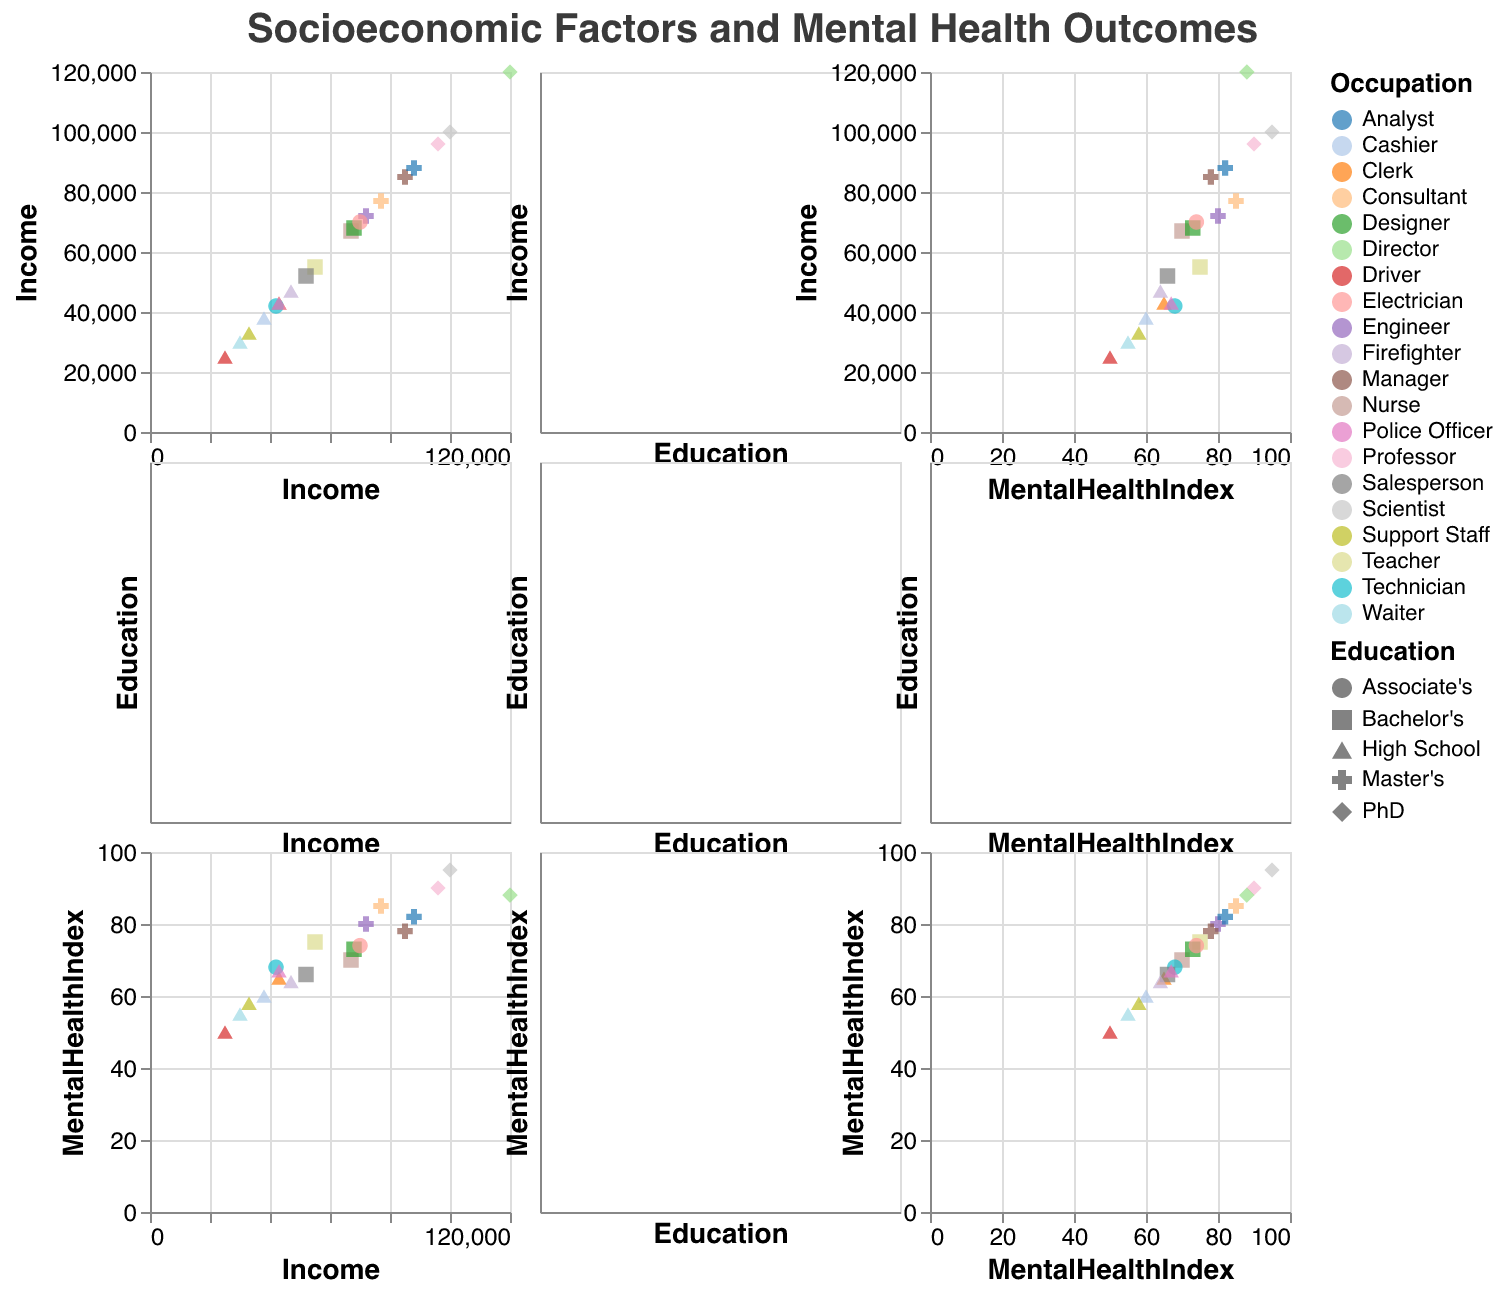What is the title of the figure? The title is typically placed at the top of the figure which helps in understanding the overall theme of the visualized data.
Answer: Socioeconomic Factors and Mental Health Outcomes How many different occupations are represented in the plot? Different occupations are usually denoted by various colors. By counting unique colors in the plot, we find the number of different occupations represented.
Answer: 20 Which education level has the highest average Mental Health Index? To determine this, identify the data points corresponding to each education level and calculate the average Mental Health Index for each. Compare the averages to find the education level with the highest value. For example, bachelor's, master’s, PhD, etc.
Answer: PhD Do people with higher income generally have better Mental Health Index scores? Look at the data points in the scatter plots related to income and mental health index to identify any noticeable trend or correlation. If higher income values align with higher Mental Health Index scores, then the trend supports this statement.
Answer: Yes Which occupation cluster appears most frequently within the $40,000 to $60,000 income range? By focusing on the scatter plot section where income values range between $40,000 and $60,000, count the number of data points for each occupation. Determine which occupation appears the most within this interval.
Answer: Various occupations appear, but 'High School' educated roles like Clerk, Police Officer, and Firefighter are common Is there a visible correlation between education level and income in the plot? Examine how the data points are distributed concerning education level and income across the plots. If a trend or pattern shows higher education levels aligning with higher incomes, that would indicate a correlation.
Answer: Yes Are people with a master's degree depicted to have a high variation in the Mental Health Index? Observe the distribution of data points corresponding to a master's degree in plots involving the Mental Health Index. A wide spread of data points indicates high variability.
Answer: Yes Between those with a Bachelors and an Associate's degree, which group tends to have a higher Mental Health Index on average? Calculate the average Mental Health Index for data points corresponding to "Bachelor's" and "Associate's" degrees. Compare these averages to determine which group tends to have a higher Mental Health Index.
Answer: Bachelor's Which education level shows the widest range in income levels? Assess the horizontal spread in plots involving income against different education levels. Identify which education level has data points covering the widest income range from lowest to highest.
Answer: PhD What is the income range for individuals with a PhD? Look at the scatter plot, particularly at the data points corresponding to individuals with a PhD, and note the minimum and maximum income values.
Answer: $96,000 to $120,000 